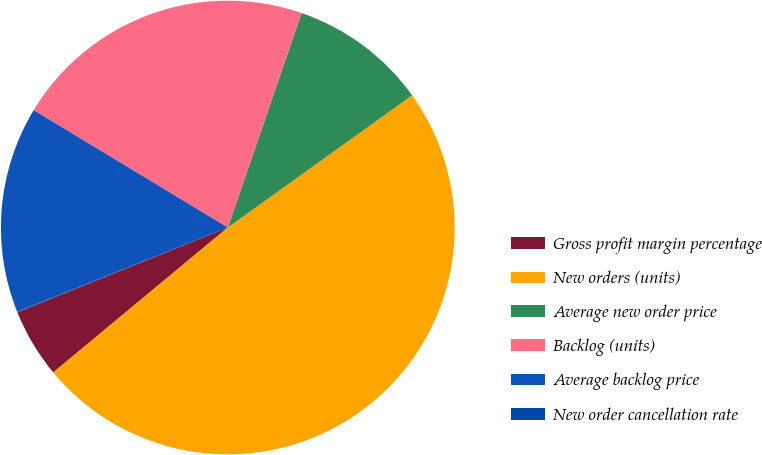Convert chart. <chart><loc_0><loc_0><loc_500><loc_500><pie_chart><fcel>Gross profit margin percentage<fcel>New orders (units)<fcel>Average new order price<fcel>Backlog (units)<fcel>Average backlog price<fcel>New order cancellation rate<nl><fcel>4.93%<fcel>48.88%<fcel>9.82%<fcel>21.62%<fcel>14.7%<fcel>0.05%<nl></chart> 